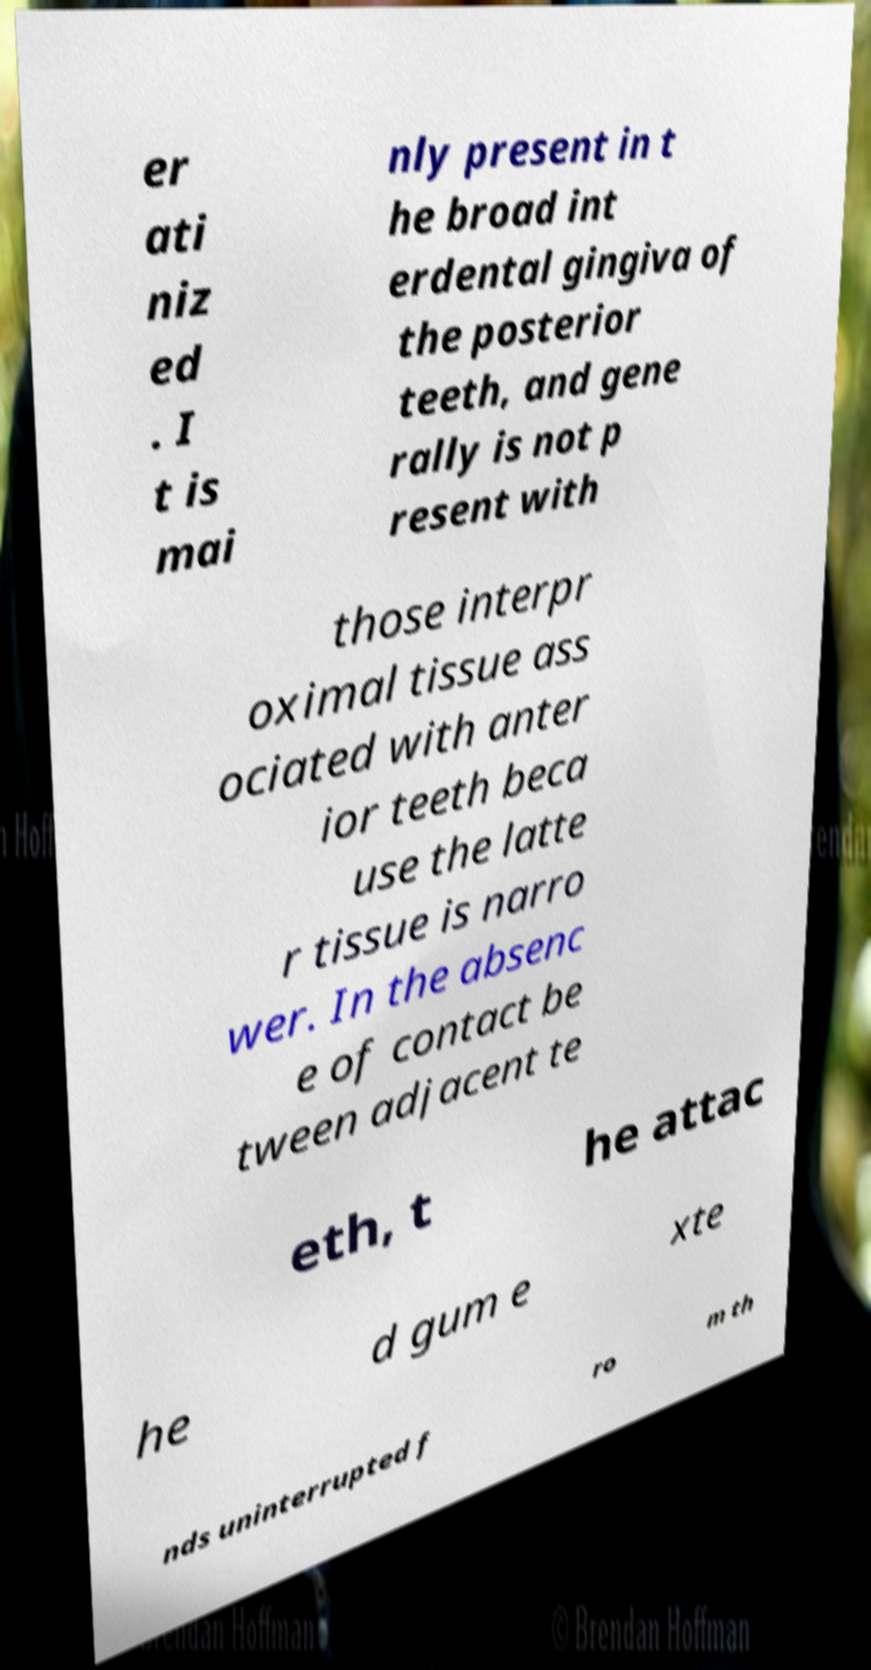Can you accurately transcribe the text from the provided image for me? er ati niz ed . I t is mai nly present in t he broad int erdental gingiva of the posterior teeth, and gene rally is not p resent with those interpr oximal tissue ass ociated with anter ior teeth beca use the latte r tissue is narro wer. In the absenc e of contact be tween adjacent te eth, t he attac he d gum e xte nds uninterrupted f ro m th 